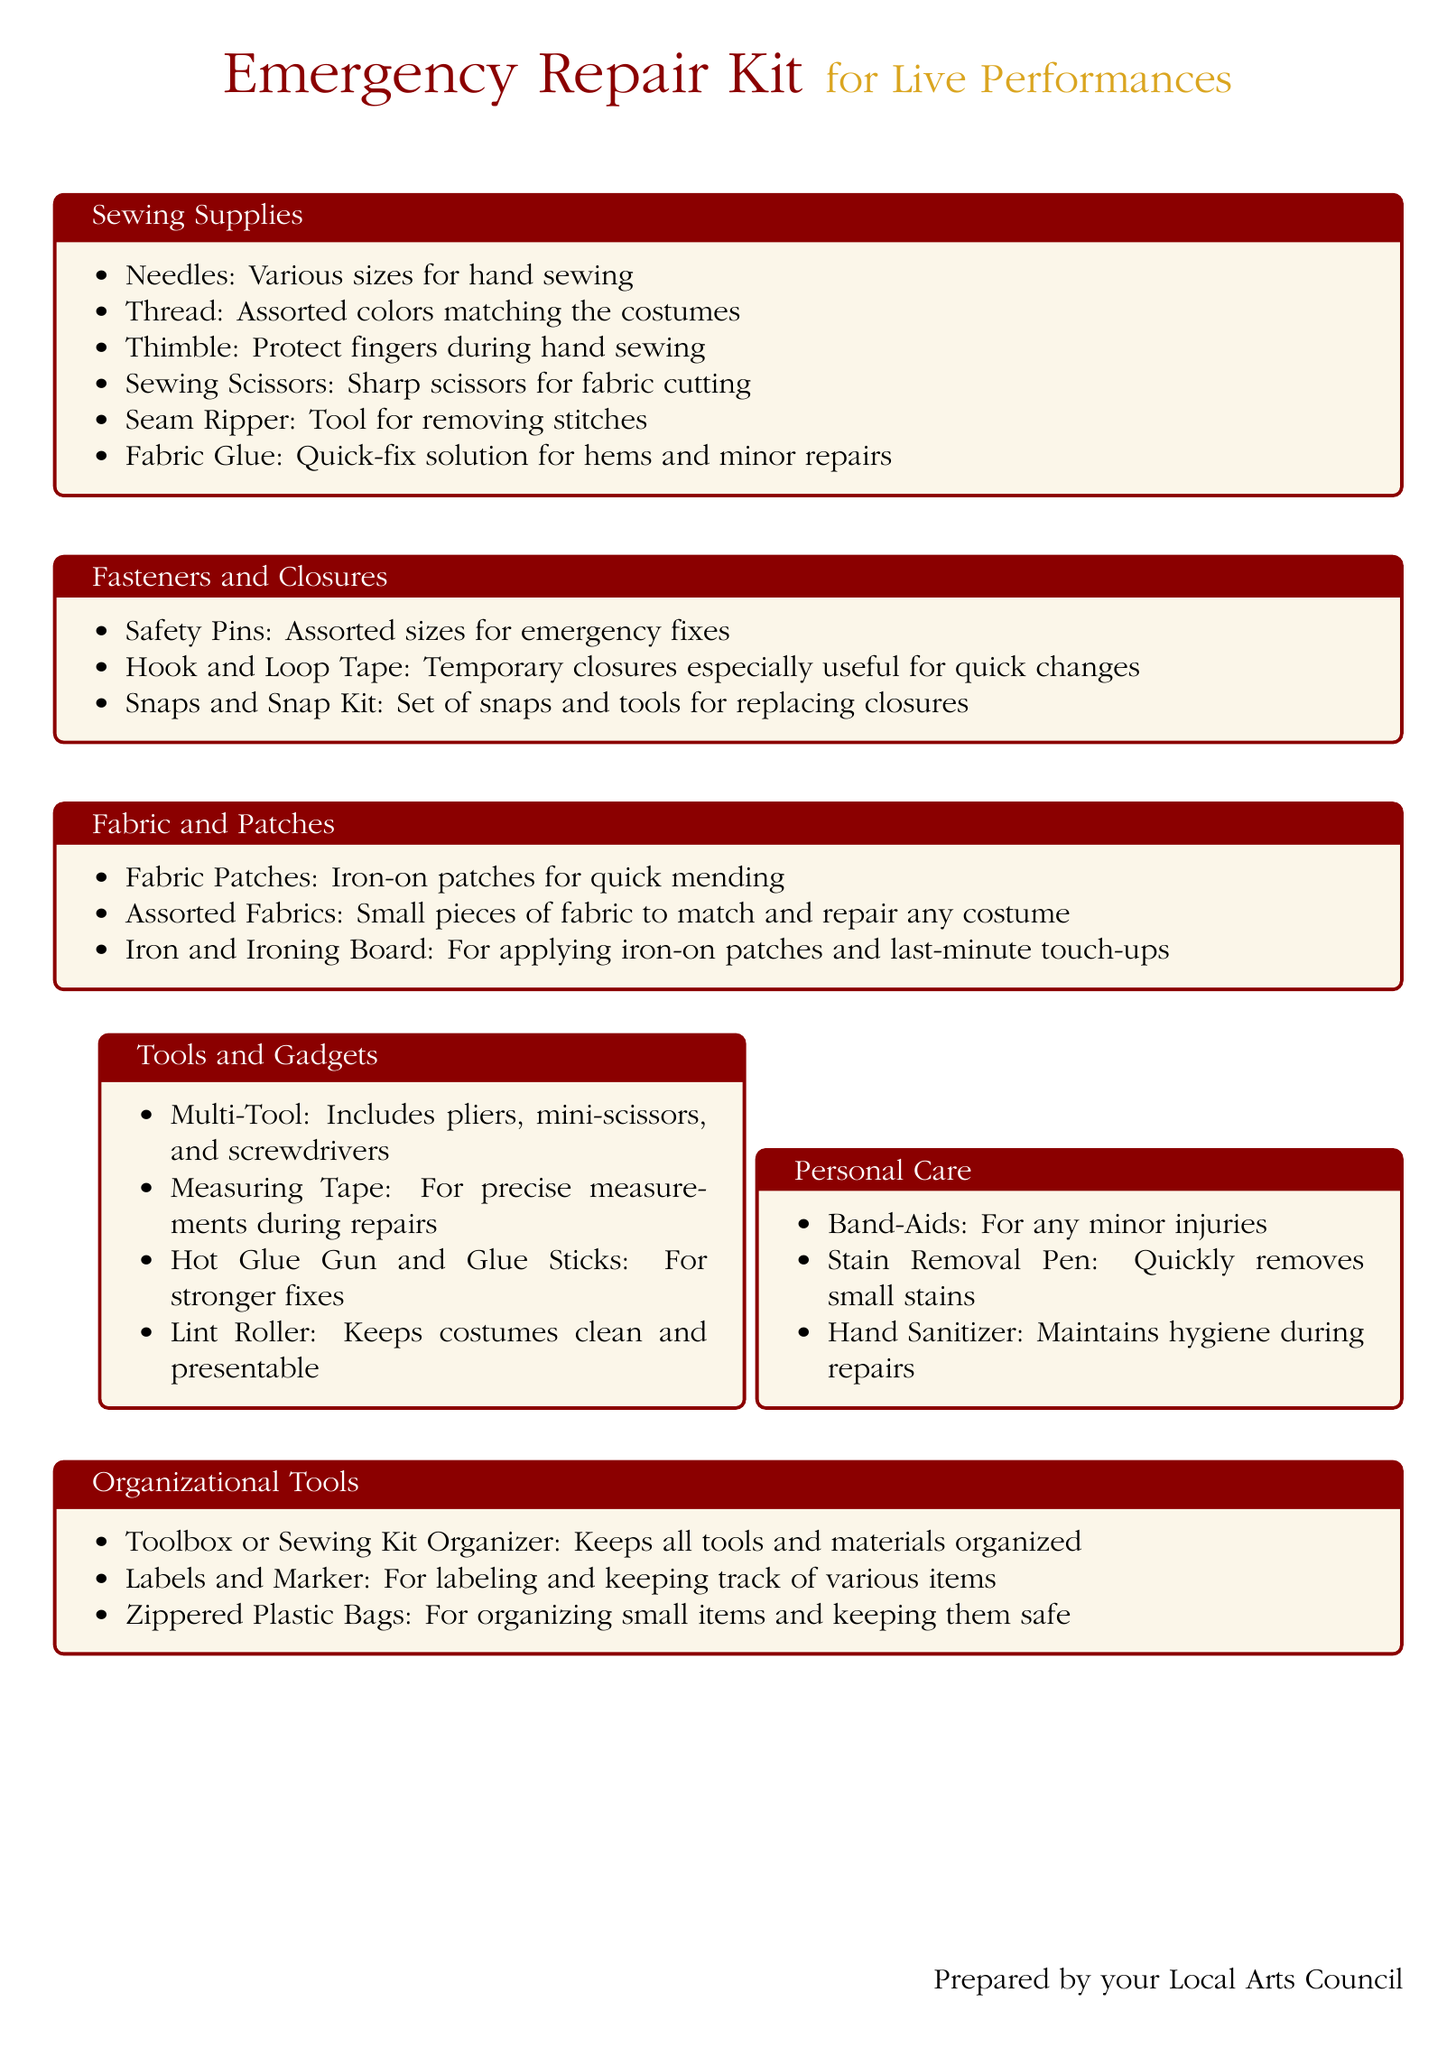What is the title of the document? The title of the document is indicated at the top of the rendered document, which is "Emergency Repair Kit."
Answer: Emergency Repair Kit What color is used for the headings? The color for the headings is specified in the document and is consistent throughout, which is described as "curtainred."
Answer: curtainred How many sewing supplies are listed? To find the number of sewing supplies, one needs to count the items in the "Sewing Supplies" section, which totals six.
Answer: 6 What type of adhesive is mentioned in the sewing supplies? The document specifies one type of adhesive under sewing supplies, which is a quick fix solution.
Answer: Fabric Glue What items are included in the Fasteners and Closures section? This section lists specific items used for fastening, which includes safety pins, hook and loop tape, and snaps.
Answer: Safety Pins, Hook and Loop Tape, Snaps How many organizational tools are listed in the document? Upon reviewing the "Organizational Tools" section, there are three items mentioned therein.
Answer: 3 What personal care item is used for injuries? The document lists a specific item under personal care for dealing with minor injuries.
Answer: Band-Aids What tool is mentioned for cleaning costumes? The document includes one specific item that helps in maintaining the cleanliness of costumes, which is a sticky roller.
Answer: Lint Roller What type of glue is mentioned in the Tools and Gadgets section? The document mentions a type of glue that offers stronger fixes in the "Tools and Gadgets" section.
Answer: Hot Glue Gun 